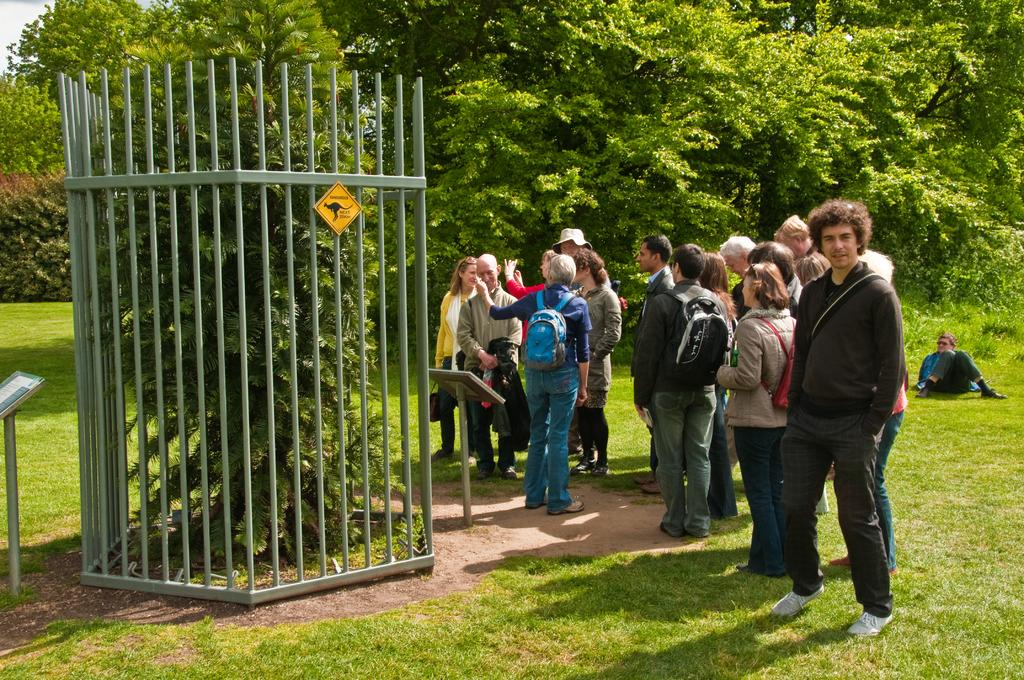What can be seen in the image involving people? There are people standing in the image. What type of natural environment is present in the image? There are trees and grass in the image. What type of structure can be seen in the image? There is a grille in the image. What else can be seen in the image that might be used for displaying items? There are stands in the image. Can you describe the seating arrangement in the image? There is a person sitting in the background of the background of the image. What type of beef is being served at the event in the image? There is no mention of beef or any food in the image; it primarily features people, trees, a grille, stands, grass, and a person sitting in the background. Can you tell me which person in the image has the most prominent chin? There is no information provided about the appearance of the people in the image, so it is impossible to determine who has the most prominent chin. 